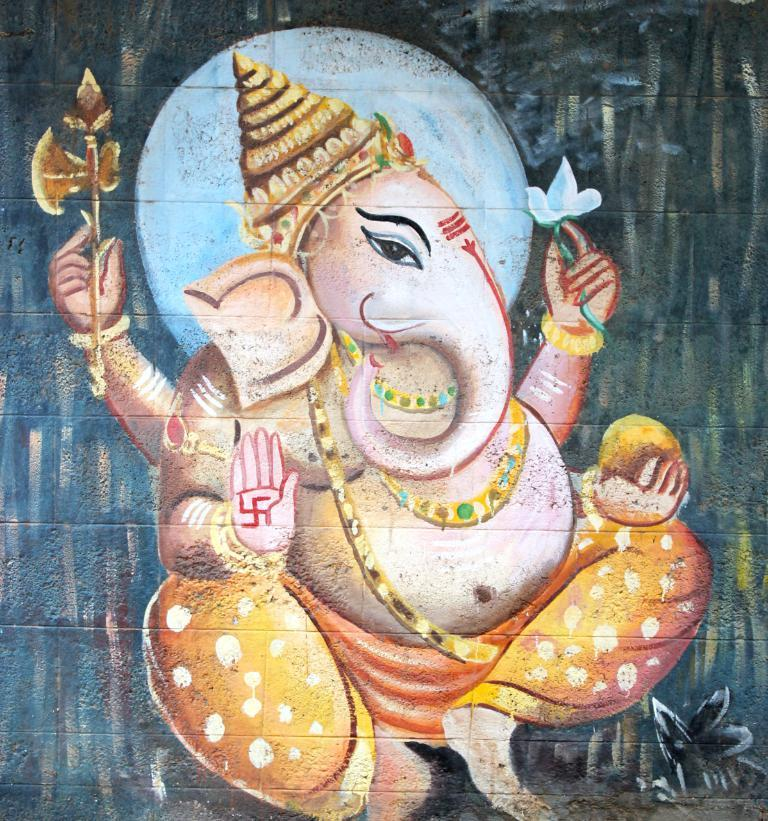What is the main subject of the image? There is a painting of an idol in the image. Can you tell me how many cobwebs are present in the painting? There is no mention of cobwebs in the image, as it features a painting of an idol. 